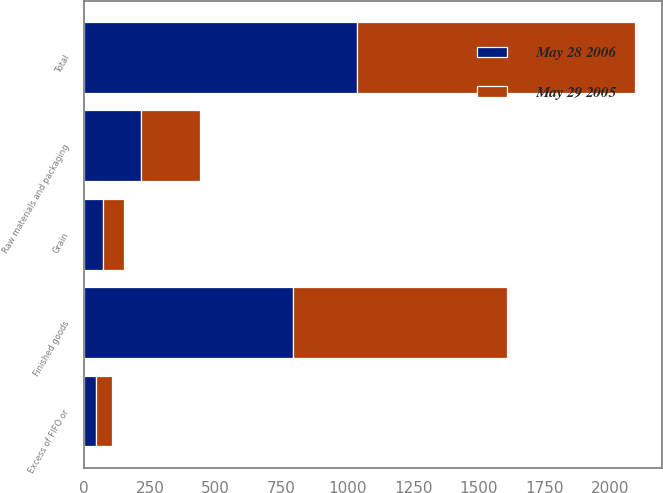Convert chart. <chart><loc_0><loc_0><loc_500><loc_500><stacked_bar_chart><ecel><fcel>Raw materials and packaging<fcel>Finished goods<fcel>Grain<fcel>Excess of FIFO or<fcel>Total<nl><fcel>May 29 2005<fcel>226<fcel>813<fcel>78<fcel>62<fcel>1055<nl><fcel>May 28 2006<fcel>214<fcel>795<fcel>73<fcel>45<fcel>1037<nl></chart> 